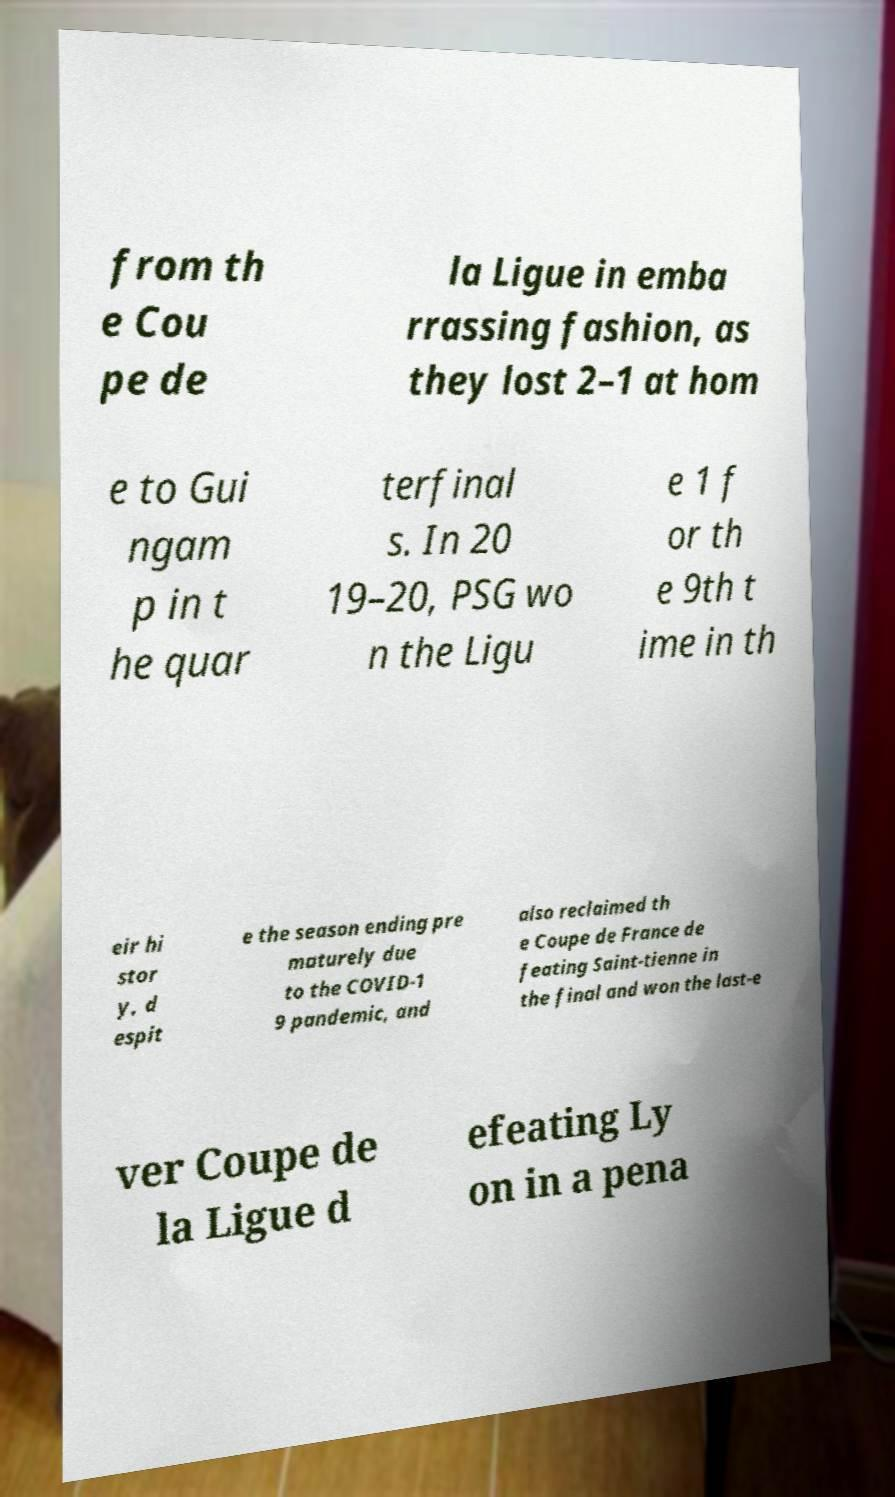Can you read and provide the text displayed in the image?This photo seems to have some interesting text. Can you extract and type it out for me? from th e Cou pe de la Ligue in emba rrassing fashion, as they lost 2–1 at hom e to Gui ngam p in t he quar terfinal s. In 20 19–20, PSG wo n the Ligu e 1 f or th e 9th t ime in th eir hi stor y, d espit e the season ending pre maturely due to the COVID-1 9 pandemic, and also reclaimed th e Coupe de France de feating Saint-tienne in the final and won the last-e ver Coupe de la Ligue d efeating Ly on in a pena 